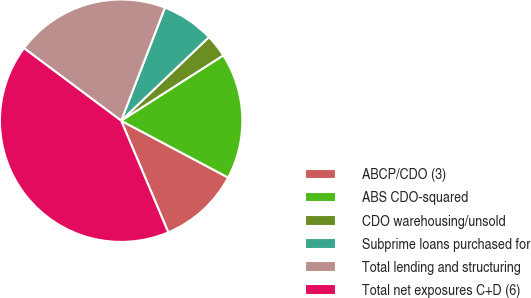<chart> <loc_0><loc_0><loc_500><loc_500><pie_chart><fcel>ABCP/CDO (3)<fcel>ABS CDO-squared<fcel>CDO warehousing/unsold<fcel>Subprime loans purchased for<fcel>Total lending and structuring<fcel>Total net exposures C+D (6)<nl><fcel>10.87%<fcel>16.83%<fcel>3.05%<fcel>7.01%<fcel>20.68%<fcel>41.56%<nl></chart> 